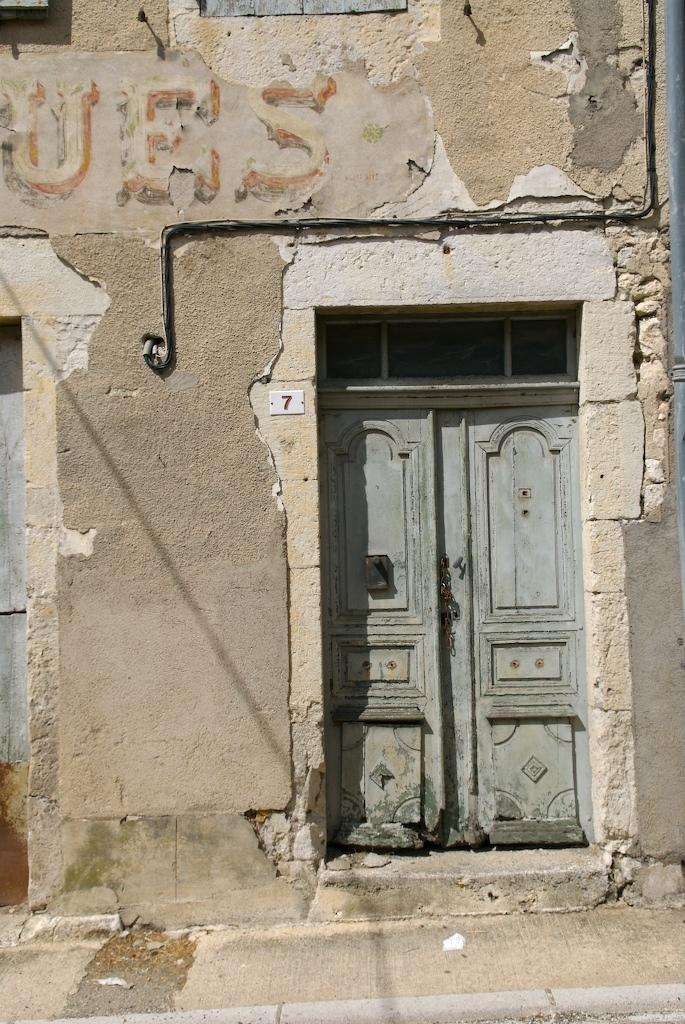What type of surface is visible in the image? There is a pavement in the image. What can be seen in the background of the image? There is a wall in the background of the image. Is there any entrance visible in the wall? Yes, there is a door in the wall. How many pages are visible in the image? There are no pages present in the image. What type of hands can be seen interacting with the door in the image? There are no hands visible in the image, and no interaction with the door is depicted. 